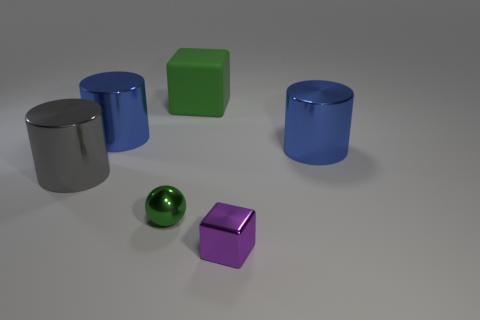Is there any other thing that has the same material as the big block?
Your response must be concise. No. How many objects are blocks behind the small metal ball or tiny purple metallic things?
Offer a very short reply. 2. Is the size of the green sphere the same as the blue metallic thing that is to the left of the big green rubber block?
Provide a succinct answer. No. How many small things are either blue metal things or cubes?
Give a very brief answer. 1. What shape is the large gray thing?
Ensure brevity in your answer.  Cylinder. What is the size of the thing that is the same color as the ball?
Provide a succinct answer. Large. Is there a large gray object made of the same material as the tiny purple object?
Keep it short and to the point. Yes. Are there more small purple metallic things than green matte balls?
Your answer should be very brief. Yes. Do the large gray thing and the tiny purple block have the same material?
Ensure brevity in your answer.  Yes. How many metal objects are either green balls or large things?
Provide a short and direct response. 4. 